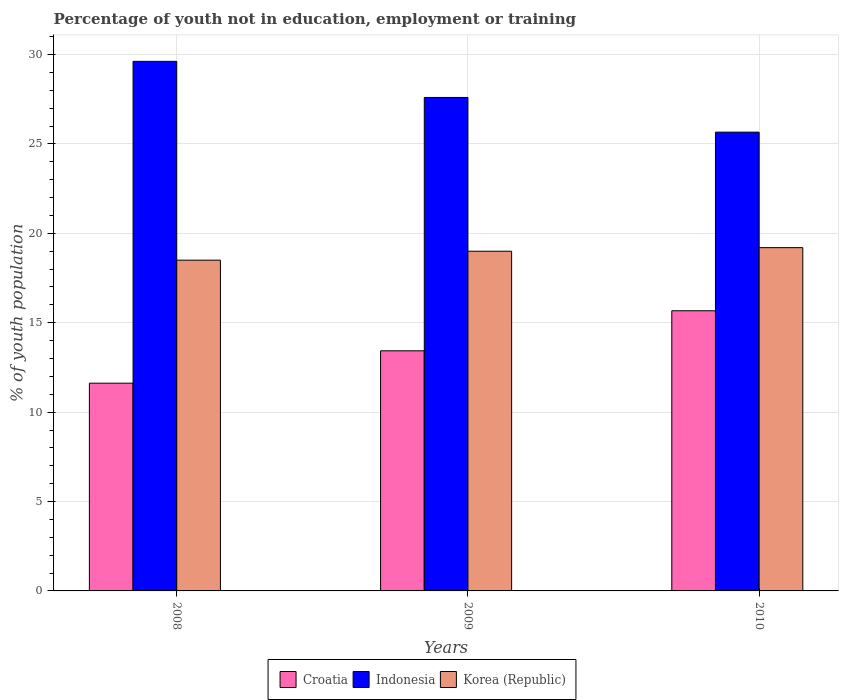How many groups of bars are there?
Offer a very short reply. 3. Are the number of bars per tick equal to the number of legend labels?
Offer a very short reply. Yes. How many bars are there on the 2nd tick from the right?
Provide a succinct answer. 3. What is the label of the 3rd group of bars from the left?
Your answer should be compact. 2010. What is the percentage of unemployed youth population in in Korea (Republic) in 2008?
Your response must be concise. 18.5. Across all years, what is the maximum percentage of unemployed youth population in in Korea (Republic)?
Ensure brevity in your answer.  19.2. Across all years, what is the minimum percentage of unemployed youth population in in Korea (Republic)?
Ensure brevity in your answer.  18.5. In which year was the percentage of unemployed youth population in in Korea (Republic) maximum?
Give a very brief answer. 2010. What is the total percentage of unemployed youth population in in Indonesia in the graph?
Your response must be concise. 82.88. What is the difference between the percentage of unemployed youth population in in Indonesia in 2008 and that in 2009?
Ensure brevity in your answer.  2.02. What is the difference between the percentage of unemployed youth population in in Indonesia in 2008 and the percentage of unemployed youth population in in Korea (Republic) in 2009?
Your response must be concise. 10.62. What is the average percentage of unemployed youth population in in Croatia per year?
Give a very brief answer. 13.57. In the year 2008, what is the difference between the percentage of unemployed youth population in in Korea (Republic) and percentage of unemployed youth population in in Croatia?
Keep it short and to the point. 6.88. In how many years, is the percentage of unemployed youth population in in Indonesia greater than 10 %?
Provide a short and direct response. 3. What is the ratio of the percentage of unemployed youth population in in Indonesia in 2008 to that in 2009?
Your answer should be compact. 1.07. Is the difference between the percentage of unemployed youth population in in Korea (Republic) in 2008 and 2009 greater than the difference between the percentage of unemployed youth population in in Croatia in 2008 and 2009?
Keep it short and to the point. Yes. What is the difference between the highest and the second highest percentage of unemployed youth population in in Croatia?
Ensure brevity in your answer.  2.24. What is the difference between the highest and the lowest percentage of unemployed youth population in in Indonesia?
Give a very brief answer. 3.96. In how many years, is the percentage of unemployed youth population in in Croatia greater than the average percentage of unemployed youth population in in Croatia taken over all years?
Provide a succinct answer. 1. Is the sum of the percentage of unemployed youth population in in Korea (Republic) in 2008 and 2010 greater than the maximum percentage of unemployed youth population in in Croatia across all years?
Your response must be concise. Yes. What does the 1st bar from the right in 2010 represents?
Make the answer very short. Korea (Republic). What is the difference between two consecutive major ticks on the Y-axis?
Provide a short and direct response. 5. Are the values on the major ticks of Y-axis written in scientific E-notation?
Offer a very short reply. No. How many legend labels are there?
Keep it short and to the point. 3. How are the legend labels stacked?
Your response must be concise. Horizontal. What is the title of the graph?
Provide a succinct answer. Percentage of youth not in education, employment or training. What is the label or title of the X-axis?
Give a very brief answer. Years. What is the label or title of the Y-axis?
Offer a very short reply. % of youth population. What is the % of youth population in Croatia in 2008?
Your answer should be very brief. 11.62. What is the % of youth population of Indonesia in 2008?
Offer a terse response. 29.62. What is the % of youth population in Korea (Republic) in 2008?
Keep it short and to the point. 18.5. What is the % of youth population in Croatia in 2009?
Ensure brevity in your answer.  13.43. What is the % of youth population in Indonesia in 2009?
Provide a succinct answer. 27.6. What is the % of youth population in Croatia in 2010?
Provide a short and direct response. 15.67. What is the % of youth population of Indonesia in 2010?
Provide a succinct answer. 25.66. What is the % of youth population of Korea (Republic) in 2010?
Offer a very short reply. 19.2. Across all years, what is the maximum % of youth population in Croatia?
Offer a very short reply. 15.67. Across all years, what is the maximum % of youth population in Indonesia?
Ensure brevity in your answer.  29.62. Across all years, what is the maximum % of youth population in Korea (Republic)?
Offer a very short reply. 19.2. Across all years, what is the minimum % of youth population of Croatia?
Ensure brevity in your answer.  11.62. Across all years, what is the minimum % of youth population in Indonesia?
Ensure brevity in your answer.  25.66. Across all years, what is the minimum % of youth population in Korea (Republic)?
Provide a succinct answer. 18.5. What is the total % of youth population in Croatia in the graph?
Provide a short and direct response. 40.72. What is the total % of youth population in Indonesia in the graph?
Provide a succinct answer. 82.88. What is the total % of youth population in Korea (Republic) in the graph?
Provide a short and direct response. 56.7. What is the difference between the % of youth population of Croatia in 2008 and that in 2009?
Make the answer very short. -1.81. What is the difference between the % of youth population of Indonesia in 2008 and that in 2009?
Give a very brief answer. 2.02. What is the difference between the % of youth population of Korea (Republic) in 2008 and that in 2009?
Your answer should be very brief. -0.5. What is the difference between the % of youth population of Croatia in 2008 and that in 2010?
Provide a short and direct response. -4.05. What is the difference between the % of youth population of Indonesia in 2008 and that in 2010?
Ensure brevity in your answer.  3.96. What is the difference between the % of youth population of Croatia in 2009 and that in 2010?
Provide a succinct answer. -2.24. What is the difference between the % of youth population of Indonesia in 2009 and that in 2010?
Ensure brevity in your answer.  1.94. What is the difference between the % of youth population of Croatia in 2008 and the % of youth population of Indonesia in 2009?
Offer a very short reply. -15.98. What is the difference between the % of youth population in Croatia in 2008 and the % of youth population in Korea (Republic) in 2009?
Offer a very short reply. -7.38. What is the difference between the % of youth population in Indonesia in 2008 and the % of youth population in Korea (Republic) in 2009?
Provide a succinct answer. 10.62. What is the difference between the % of youth population of Croatia in 2008 and the % of youth population of Indonesia in 2010?
Your answer should be very brief. -14.04. What is the difference between the % of youth population of Croatia in 2008 and the % of youth population of Korea (Republic) in 2010?
Provide a succinct answer. -7.58. What is the difference between the % of youth population in Indonesia in 2008 and the % of youth population in Korea (Republic) in 2010?
Your answer should be compact. 10.42. What is the difference between the % of youth population in Croatia in 2009 and the % of youth population in Indonesia in 2010?
Your response must be concise. -12.23. What is the difference between the % of youth population in Croatia in 2009 and the % of youth population in Korea (Republic) in 2010?
Make the answer very short. -5.77. What is the difference between the % of youth population of Indonesia in 2009 and the % of youth population of Korea (Republic) in 2010?
Make the answer very short. 8.4. What is the average % of youth population in Croatia per year?
Your answer should be very brief. 13.57. What is the average % of youth population in Indonesia per year?
Your answer should be very brief. 27.63. In the year 2008, what is the difference between the % of youth population of Croatia and % of youth population of Indonesia?
Provide a short and direct response. -18. In the year 2008, what is the difference between the % of youth population in Croatia and % of youth population in Korea (Republic)?
Provide a succinct answer. -6.88. In the year 2008, what is the difference between the % of youth population of Indonesia and % of youth population of Korea (Republic)?
Make the answer very short. 11.12. In the year 2009, what is the difference between the % of youth population of Croatia and % of youth population of Indonesia?
Your answer should be compact. -14.17. In the year 2009, what is the difference between the % of youth population of Croatia and % of youth population of Korea (Republic)?
Your answer should be very brief. -5.57. In the year 2009, what is the difference between the % of youth population in Indonesia and % of youth population in Korea (Republic)?
Your answer should be very brief. 8.6. In the year 2010, what is the difference between the % of youth population of Croatia and % of youth population of Indonesia?
Your answer should be very brief. -9.99. In the year 2010, what is the difference between the % of youth population in Croatia and % of youth population in Korea (Republic)?
Make the answer very short. -3.53. In the year 2010, what is the difference between the % of youth population of Indonesia and % of youth population of Korea (Republic)?
Ensure brevity in your answer.  6.46. What is the ratio of the % of youth population of Croatia in 2008 to that in 2009?
Provide a short and direct response. 0.87. What is the ratio of the % of youth population in Indonesia in 2008 to that in 2009?
Provide a short and direct response. 1.07. What is the ratio of the % of youth population in Korea (Republic) in 2008 to that in 2009?
Make the answer very short. 0.97. What is the ratio of the % of youth population of Croatia in 2008 to that in 2010?
Your answer should be very brief. 0.74. What is the ratio of the % of youth population of Indonesia in 2008 to that in 2010?
Ensure brevity in your answer.  1.15. What is the ratio of the % of youth population in Korea (Republic) in 2008 to that in 2010?
Give a very brief answer. 0.96. What is the ratio of the % of youth population in Indonesia in 2009 to that in 2010?
Keep it short and to the point. 1.08. What is the ratio of the % of youth population in Korea (Republic) in 2009 to that in 2010?
Provide a succinct answer. 0.99. What is the difference between the highest and the second highest % of youth population of Croatia?
Your response must be concise. 2.24. What is the difference between the highest and the second highest % of youth population of Indonesia?
Make the answer very short. 2.02. What is the difference between the highest and the second highest % of youth population in Korea (Republic)?
Your response must be concise. 0.2. What is the difference between the highest and the lowest % of youth population in Croatia?
Your response must be concise. 4.05. What is the difference between the highest and the lowest % of youth population of Indonesia?
Your answer should be compact. 3.96. 